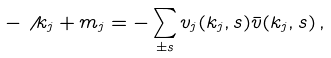<formula> <loc_0><loc_0><loc_500><loc_500>- \not \, k _ { j } + m _ { j } = - \sum _ { \pm s } v _ { j } ( k _ { j } , s ) \bar { v } ( k _ { j } , s ) \, ,</formula> 